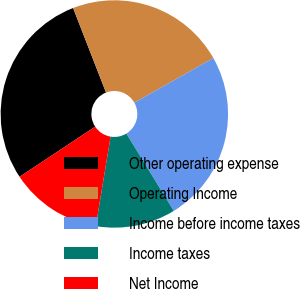Convert chart. <chart><loc_0><loc_0><loc_500><loc_500><pie_chart><fcel>Other operating expense<fcel>Operating Income<fcel>Income before income taxes<fcel>Income taxes<fcel>Net Income<nl><fcel>28.41%<fcel>22.73%<fcel>24.43%<fcel>11.36%<fcel>13.07%<nl></chart> 